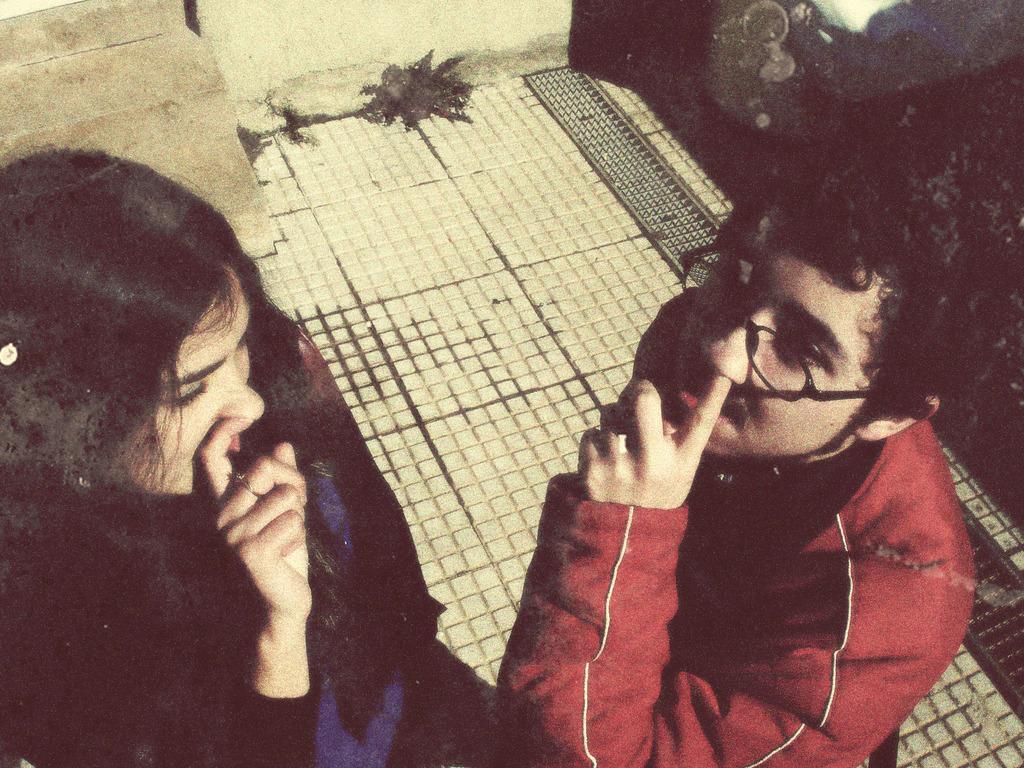How would you summarize this image in a sentence or two? In this picture we can see a woman and man, he wore spectacles and a red color dress. 